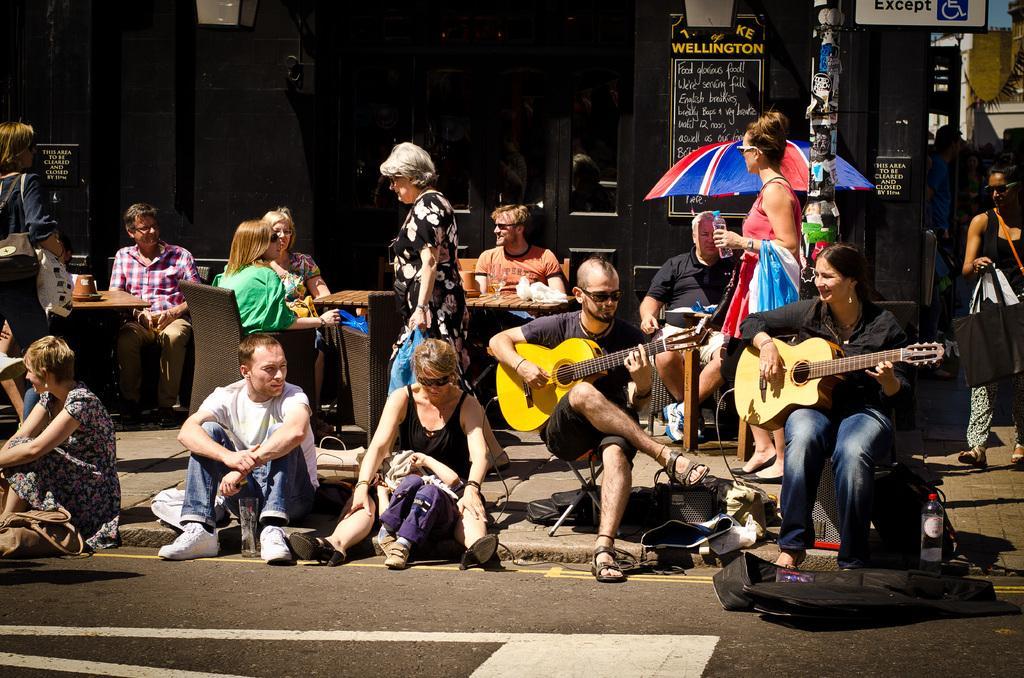Describe this image in one or two sentences. In this image we can see two people sitting and playing guitar. At the bottom there is a road and we can see people sitting and some of them are walking. In the background there is a parasol and we can see boards. There is a building. On the right there is a pole. We can see tables and chairs. There are things placed on the tables. There is an object. 